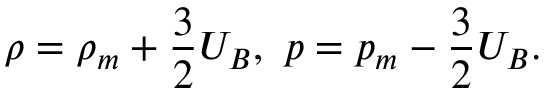<formula> <loc_0><loc_0><loc_500><loc_500>\rho = \rho _ { m } + \frac { 3 } { 2 } U _ { B } , \ p = p _ { m } - \frac { 3 } { 2 } U _ { B } .</formula> 